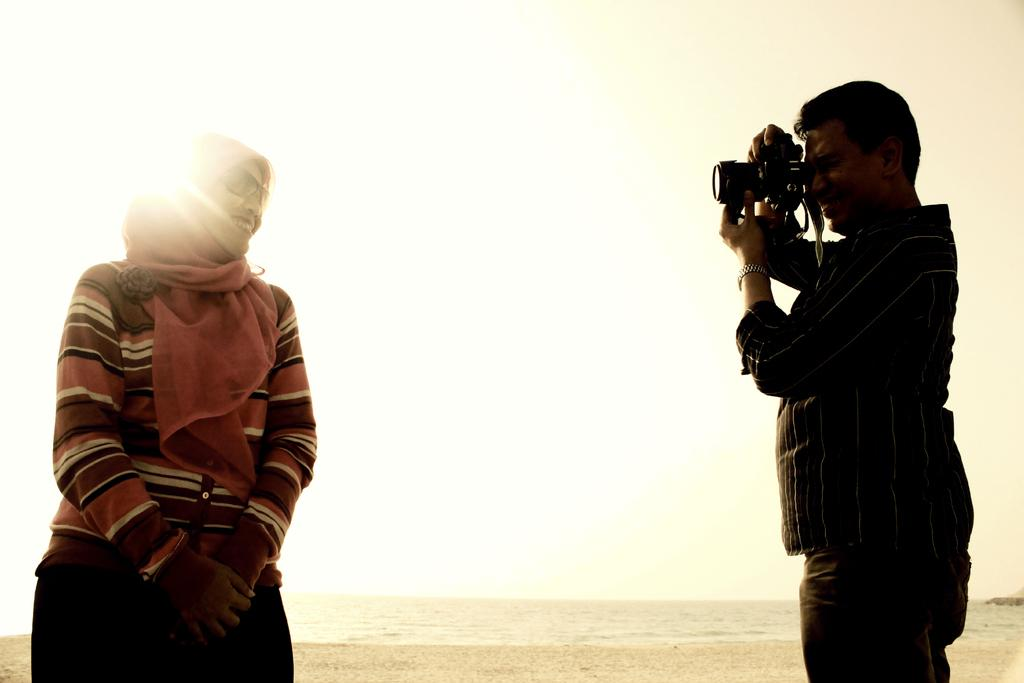Who is the main subject in the image? There is a woman in the image. What is the woman doing in the image? The woman is standing and posing for a photo. Who else is present in the image? There is a man in the image. What is the man doing in the image? The man is taking a photo of the woman. What type of steel is being used to capture the woman's breath in the image? There is no steel or reference to breath in the image; it simply shows a woman posing for a photo and a man taking the photo. 